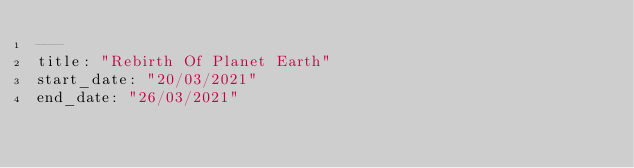Convert code to text. <code><loc_0><loc_0><loc_500><loc_500><_YAML_>---
title: "Rebirth Of Planet Earth"
start_date: "20/03/2021"
end_date: "26/03/2021"</code> 